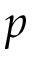<formula> <loc_0><loc_0><loc_500><loc_500>p</formula> 